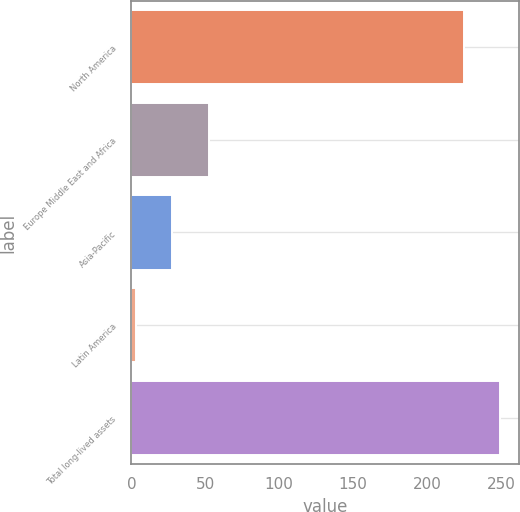<chart> <loc_0><loc_0><loc_500><loc_500><bar_chart><fcel>North America<fcel>Europe Middle East and Africa<fcel>Asia-Pacific<fcel>Latin America<fcel>Total long-lived assets<nl><fcel>225<fcel>52.2<fcel>27.6<fcel>3<fcel>249.6<nl></chart> 